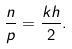Convert formula to latex. <formula><loc_0><loc_0><loc_500><loc_500>\frac { n } { p } = \frac { k h } { 2 } .</formula> 